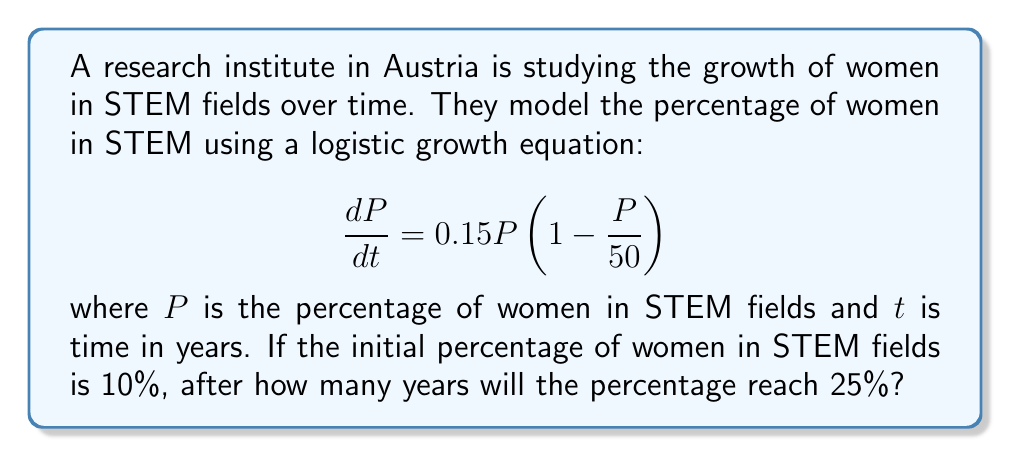Could you help me with this problem? To solve this problem, we'll use the logistic growth model and integrate the differential equation.

1) The given logistic growth equation is:
   $$\frac{dP}{dt} = 0.15P(1 - \frac{P}{50})$$

2) We can separate the variables:
   $$\frac{dP}{P(1 - \frac{P}{50})} = 0.15dt$$

3) Integrating both sides:
   $$\int \frac{dP}{P(1 - \frac{P}{50})} = \int 0.15dt$$

4) The left-hand side can be integrated using partial fractions:
   $$\ln|P| - \ln|50-P| = 0.15t + C$$

5) Simplifying and applying the exponential function to both sides:
   $$\frac{P}{50-P} = Ae^{0.15t}$$, where $A = e^C$

6) Solving for $P$:
   $$P = \frac{50Ae^{0.15t}}{1 + Ae^{0.15t}}$$

7) Using the initial condition $P(0) = 10$, we can find $A$:
   $$10 = \frac{50A}{1 + A}$$
   $$A = \frac{1}{4}$$

8) Now our equation is:
   $$P = \frac{50(\frac{1}{4})e^{0.15t}}{1 + (\frac{1}{4})e^{0.15t}} = \frac{50}{4e^{-0.15t} + 1}$$

9) We want to find $t$ when $P = 25$:
   $$25 = \frac{50}{4e^{-0.15t} + 1}$$

10) Solving for $t$:
    $$4e^{-0.15t} + 1 = 2$$
    $$4e^{-0.15t} = 1$$
    $$e^{-0.15t} = \frac{1}{4}$$
    $$-0.15t = \ln(\frac{1}{4}) = -\ln(4)$$
    $$t = \frac{\ln(4)}{0.15} \approx 9.21$$

Therefore, it will take approximately 9.21 years for the percentage of women in STEM fields to reach 25%.
Answer: 9.21 years 